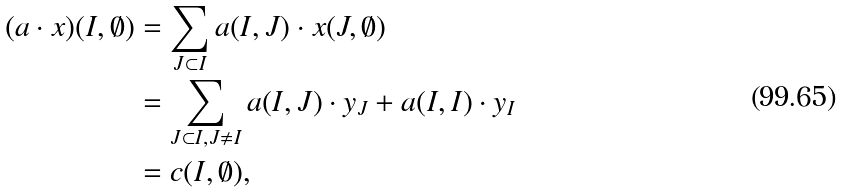<formula> <loc_0><loc_0><loc_500><loc_500>( a \cdot x ) ( I , \emptyset ) & = \sum _ { J \subset I } a ( I , J ) \cdot x ( J , \emptyset ) \\ & = \sum _ { J \subset I , J \neq I } a ( I , J ) \cdot y _ { J } + a ( I , I ) \cdot y _ { I } \\ & = c ( I , \emptyset ) ,</formula> 